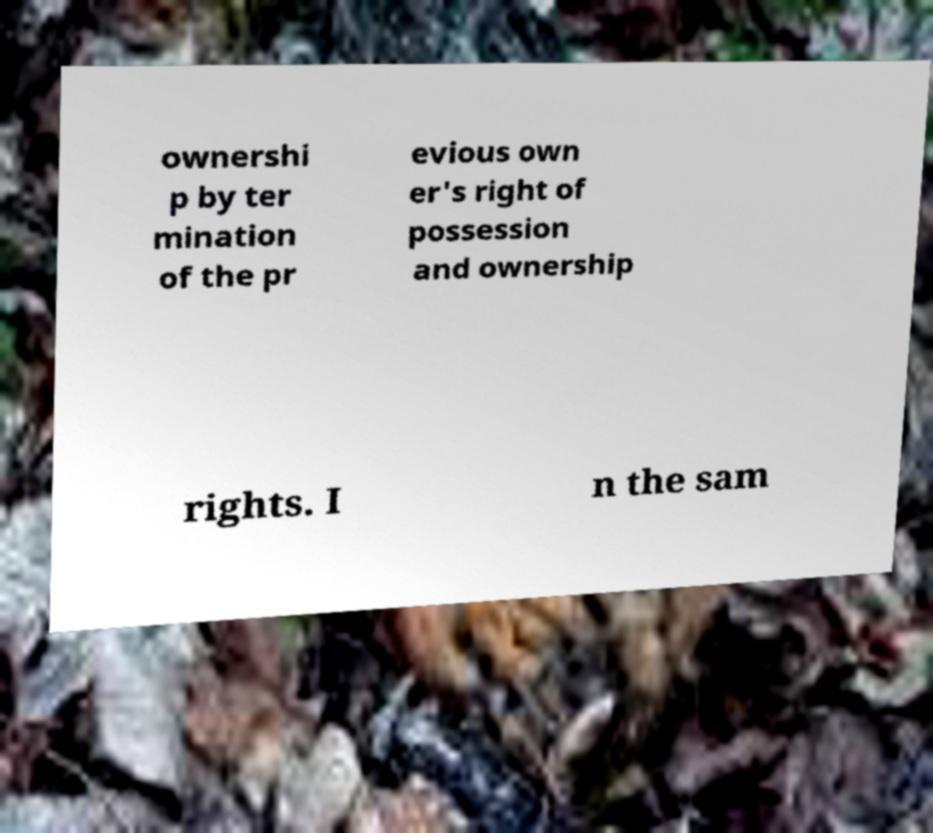What messages or text are displayed in this image? I need them in a readable, typed format. ownershi p by ter mination of the pr evious own er's right of possession and ownership rights. I n the sam 